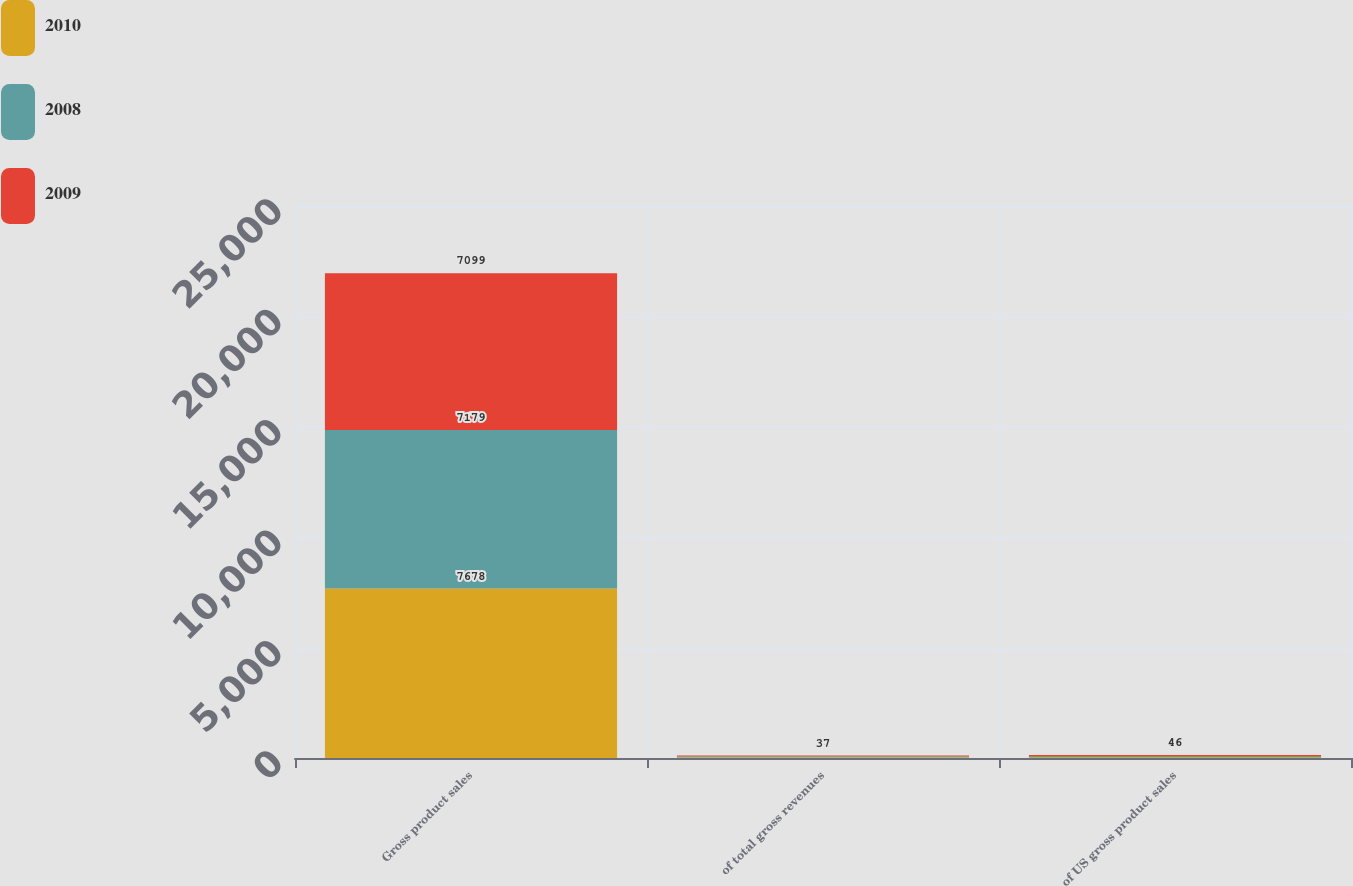Convert chart to OTSL. <chart><loc_0><loc_0><loc_500><loc_500><stacked_bar_chart><ecel><fcel>Gross product sales<fcel>of total gross revenues<fcel>of US gross product sales<nl><fcel>2010<fcel>7678<fcel>38<fcel>47<nl><fcel>2008<fcel>7179<fcel>37<fcel>46<nl><fcel>2009<fcel>7099<fcel>37<fcel>46<nl></chart> 